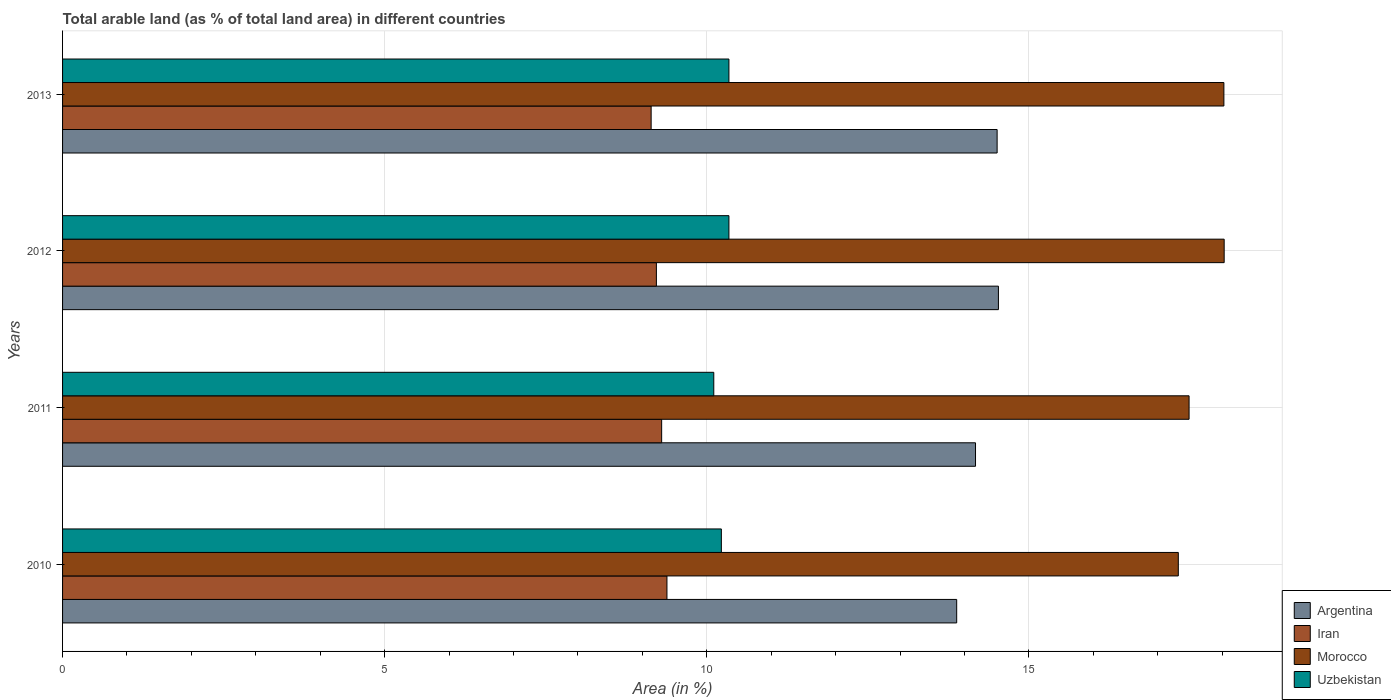How many different coloured bars are there?
Your answer should be very brief. 4. How many groups of bars are there?
Your response must be concise. 4. Are the number of bars per tick equal to the number of legend labels?
Your answer should be compact. Yes. Are the number of bars on each tick of the Y-axis equal?
Your answer should be compact. Yes. What is the label of the 1st group of bars from the top?
Offer a very short reply. 2013. In how many cases, is the number of bars for a given year not equal to the number of legend labels?
Offer a terse response. 0. What is the percentage of arable land in Uzbekistan in 2013?
Offer a terse response. 10.34. Across all years, what is the maximum percentage of arable land in Uzbekistan?
Ensure brevity in your answer.  10.34. Across all years, what is the minimum percentage of arable land in Uzbekistan?
Provide a succinct answer. 10.11. What is the total percentage of arable land in Iran in the graph?
Your answer should be compact. 37.03. What is the difference between the percentage of arable land in Morocco in 2010 and that in 2012?
Your response must be concise. -0.71. What is the difference between the percentage of arable land in Argentina in 2011 and the percentage of arable land in Morocco in 2012?
Ensure brevity in your answer.  -3.86. What is the average percentage of arable land in Uzbekistan per year?
Keep it short and to the point. 10.26. In the year 2011, what is the difference between the percentage of arable land in Argentina and percentage of arable land in Iran?
Provide a succinct answer. 4.87. What is the ratio of the percentage of arable land in Uzbekistan in 2010 to that in 2013?
Give a very brief answer. 0.99. Is the percentage of arable land in Argentina in 2011 less than that in 2012?
Your answer should be compact. Yes. What is the difference between the highest and the second highest percentage of arable land in Uzbekistan?
Your response must be concise. 0. What is the difference between the highest and the lowest percentage of arable land in Uzbekistan?
Your answer should be compact. 0.24. Is the sum of the percentage of arable land in Iran in 2010 and 2012 greater than the maximum percentage of arable land in Morocco across all years?
Offer a terse response. Yes. What does the 3rd bar from the top in 2011 represents?
Give a very brief answer. Iran. What does the 1st bar from the bottom in 2010 represents?
Give a very brief answer. Argentina. Is it the case that in every year, the sum of the percentage of arable land in Uzbekistan and percentage of arable land in Morocco is greater than the percentage of arable land in Argentina?
Offer a terse response. Yes. Are all the bars in the graph horizontal?
Your response must be concise. Yes. What is the difference between two consecutive major ticks on the X-axis?
Keep it short and to the point. 5. Are the values on the major ticks of X-axis written in scientific E-notation?
Offer a terse response. No. Does the graph contain any zero values?
Keep it short and to the point. No. How are the legend labels stacked?
Provide a short and direct response. Vertical. What is the title of the graph?
Keep it short and to the point. Total arable land (as % of total land area) in different countries. Does "Qatar" appear as one of the legend labels in the graph?
Your response must be concise. No. What is the label or title of the X-axis?
Ensure brevity in your answer.  Area (in %). What is the Area (in %) of Argentina in 2010?
Give a very brief answer. 13.88. What is the Area (in %) of Iran in 2010?
Your answer should be compact. 9.38. What is the Area (in %) in Morocco in 2010?
Your answer should be compact. 17.32. What is the Area (in %) of Uzbekistan in 2010?
Your answer should be compact. 10.23. What is the Area (in %) of Argentina in 2011?
Ensure brevity in your answer.  14.17. What is the Area (in %) in Iran in 2011?
Ensure brevity in your answer.  9.3. What is the Area (in %) in Morocco in 2011?
Provide a succinct answer. 17.49. What is the Area (in %) in Uzbekistan in 2011?
Make the answer very short. 10.11. What is the Area (in %) in Argentina in 2012?
Provide a short and direct response. 14.53. What is the Area (in %) of Iran in 2012?
Make the answer very short. 9.22. What is the Area (in %) in Morocco in 2012?
Make the answer very short. 18.03. What is the Area (in %) of Uzbekistan in 2012?
Your answer should be very brief. 10.34. What is the Area (in %) of Argentina in 2013?
Your answer should be compact. 14.51. What is the Area (in %) in Iran in 2013?
Offer a terse response. 9.14. What is the Area (in %) in Morocco in 2013?
Make the answer very short. 18.03. What is the Area (in %) of Uzbekistan in 2013?
Offer a terse response. 10.34. Across all years, what is the maximum Area (in %) of Argentina?
Make the answer very short. 14.53. Across all years, what is the maximum Area (in %) in Iran?
Keep it short and to the point. 9.38. Across all years, what is the maximum Area (in %) of Morocco?
Provide a short and direct response. 18.03. Across all years, what is the maximum Area (in %) in Uzbekistan?
Provide a short and direct response. 10.34. Across all years, what is the minimum Area (in %) in Argentina?
Make the answer very short. 13.88. Across all years, what is the minimum Area (in %) of Iran?
Your answer should be very brief. 9.14. Across all years, what is the minimum Area (in %) of Morocco?
Give a very brief answer. 17.32. Across all years, what is the minimum Area (in %) in Uzbekistan?
Give a very brief answer. 10.11. What is the total Area (in %) in Argentina in the graph?
Keep it short and to the point. 57.08. What is the total Area (in %) of Iran in the graph?
Provide a succinct answer. 37.03. What is the total Area (in %) in Morocco in the graph?
Ensure brevity in your answer.  70.86. What is the total Area (in %) of Uzbekistan in the graph?
Your answer should be very brief. 41.02. What is the difference between the Area (in %) of Argentina in 2010 and that in 2011?
Ensure brevity in your answer.  -0.29. What is the difference between the Area (in %) of Iran in 2010 and that in 2011?
Your answer should be very brief. 0.08. What is the difference between the Area (in %) of Morocco in 2010 and that in 2011?
Your answer should be very brief. -0.17. What is the difference between the Area (in %) of Uzbekistan in 2010 and that in 2011?
Your answer should be very brief. 0.12. What is the difference between the Area (in %) in Argentina in 2010 and that in 2012?
Provide a short and direct response. -0.65. What is the difference between the Area (in %) in Iran in 2010 and that in 2012?
Give a very brief answer. 0.16. What is the difference between the Area (in %) of Morocco in 2010 and that in 2012?
Offer a terse response. -0.71. What is the difference between the Area (in %) in Uzbekistan in 2010 and that in 2012?
Your answer should be very brief. -0.12. What is the difference between the Area (in %) of Argentina in 2010 and that in 2013?
Provide a succinct answer. -0.63. What is the difference between the Area (in %) in Iran in 2010 and that in 2013?
Your response must be concise. 0.25. What is the difference between the Area (in %) of Morocco in 2010 and that in 2013?
Offer a very short reply. -0.71. What is the difference between the Area (in %) in Uzbekistan in 2010 and that in 2013?
Your answer should be very brief. -0.12. What is the difference between the Area (in %) in Argentina in 2011 and that in 2012?
Keep it short and to the point. -0.36. What is the difference between the Area (in %) in Iran in 2011 and that in 2012?
Provide a succinct answer. 0.08. What is the difference between the Area (in %) in Morocco in 2011 and that in 2012?
Your answer should be compact. -0.54. What is the difference between the Area (in %) in Uzbekistan in 2011 and that in 2012?
Your answer should be compact. -0.24. What is the difference between the Area (in %) of Argentina in 2011 and that in 2013?
Offer a very short reply. -0.34. What is the difference between the Area (in %) in Iran in 2011 and that in 2013?
Provide a succinct answer. 0.16. What is the difference between the Area (in %) of Morocco in 2011 and that in 2013?
Offer a very short reply. -0.54. What is the difference between the Area (in %) of Uzbekistan in 2011 and that in 2013?
Give a very brief answer. -0.24. What is the difference between the Area (in %) in Argentina in 2012 and that in 2013?
Give a very brief answer. 0.02. What is the difference between the Area (in %) of Iran in 2012 and that in 2013?
Keep it short and to the point. 0.08. What is the difference between the Area (in %) of Morocco in 2012 and that in 2013?
Provide a succinct answer. 0. What is the difference between the Area (in %) of Uzbekistan in 2012 and that in 2013?
Your response must be concise. 0. What is the difference between the Area (in %) of Argentina in 2010 and the Area (in %) of Iran in 2011?
Give a very brief answer. 4.58. What is the difference between the Area (in %) in Argentina in 2010 and the Area (in %) in Morocco in 2011?
Your response must be concise. -3.61. What is the difference between the Area (in %) in Argentina in 2010 and the Area (in %) in Uzbekistan in 2011?
Give a very brief answer. 3.77. What is the difference between the Area (in %) of Iran in 2010 and the Area (in %) of Morocco in 2011?
Ensure brevity in your answer.  -8.1. What is the difference between the Area (in %) of Iran in 2010 and the Area (in %) of Uzbekistan in 2011?
Give a very brief answer. -0.73. What is the difference between the Area (in %) of Morocco in 2010 and the Area (in %) of Uzbekistan in 2011?
Your answer should be very brief. 7.21. What is the difference between the Area (in %) of Argentina in 2010 and the Area (in %) of Iran in 2012?
Make the answer very short. 4.66. What is the difference between the Area (in %) in Argentina in 2010 and the Area (in %) in Morocco in 2012?
Your response must be concise. -4.15. What is the difference between the Area (in %) of Argentina in 2010 and the Area (in %) of Uzbekistan in 2012?
Ensure brevity in your answer.  3.54. What is the difference between the Area (in %) of Iran in 2010 and the Area (in %) of Morocco in 2012?
Provide a succinct answer. -8.65. What is the difference between the Area (in %) of Iran in 2010 and the Area (in %) of Uzbekistan in 2012?
Your answer should be very brief. -0.96. What is the difference between the Area (in %) in Morocco in 2010 and the Area (in %) in Uzbekistan in 2012?
Provide a succinct answer. 6.98. What is the difference between the Area (in %) in Argentina in 2010 and the Area (in %) in Iran in 2013?
Keep it short and to the point. 4.74. What is the difference between the Area (in %) in Argentina in 2010 and the Area (in %) in Morocco in 2013?
Provide a succinct answer. -4.15. What is the difference between the Area (in %) of Argentina in 2010 and the Area (in %) of Uzbekistan in 2013?
Provide a short and direct response. 3.54. What is the difference between the Area (in %) in Iran in 2010 and the Area (in %) in Morocco in 2013?
Make the answer very short. -8.64. What is the difference between the Area (in %) in Iran in 2010 and the Area (in %) in Uzbekistan in 2013?
Your answer should be very brief. -0.96. What is the difference between the Area (in %) of Morocco in 2010 and the Area (in %) of Uzbekistan in 2013?
Offer a very short reply. 6.98. What is the difference between the Area (in %) of Argentina in 2011 and the Area (in %) of Iran in 2012?
Your answer should be very brief. 4.95. What is the difference between the Area (in %) in Argentina in 2011 and the Area (in %) in Morocco in 2012?
Keep it short and to the point. -3.86. What is the difference between the Area (in %) of Argentina in 2011 and the Area (in %) of Uzbekistan in 2012?
Provide a short and direct response. 3.83. What is the difference between the Area (in %) in Iran in 2011 and the Area (in %) in Morocco in 2012?
Your answer should be compact. -8.73. What is the difference between the Area (in %) of Iran in 2011 and the Area (in %) of Uzbekistan in 2012?
Make the answer very short. -1.04. What is the difference between the Area (in %) in Morocco in 2011 and the Area (in %) in Uzbekistan in 2012?
Ensure brevity in your answer.  7.14. What is the difference between the Area (in %) of Argentina in 2011 and the Area (in %) of Iran in 2013?
Your response must be concise. 5.04. What is the difference between the Area (in %) of Argentina in 2011 and the Area (in %) of Morocco in 2013?
Keep it short and to the point. -3.86. What is the difference between the Area (in %) of Argentina in 2011 and the Area (in %) of Uzbekistan in 2013?
Provide a short and direct response. 3.83. What is the difference between the Area (in %) of Iran in 2011 and the Area (in %) of Morocco in 2013?
Provide a succinct answer. -8.73. What is the difference between the Area (in %) of Iran in 2011 and the Area (in %) of Uzbekistan in 2013?
Your answer should be compact. -1.04. What is the difference between the Area (in %) of Morocco in 2011 and the Area (in %) of Uzbekistan in 2013?
Offer a terse response. 7.14. What is the difference between the Area (in %) in Argentina in 2012 and the Area (in %) in Iran in 2013?
Offer a terse response. 5.39. What is the difference between the Area (in %) in Argentina in 2012 and the Area (in %) in Morocco in 2013?
Your answer should be compact. -3.5. What is the difference between the Area (in %) of Argentina in 2012 and the Area (in %) of Uzbekistan in 2013?
Your answer should be compact. 4.18. What is the difference between the Area (in %) in Iran in 2012 and the Area (in %) in Morocco in 2013?
Offer a terse response. -8.81. What is the difference between the Area (in %) in Iran in 2012 and the Area (in %) in Uzbekistan in 2013?
Your answer should be compact. -1.13. What is the difference between the Area (in %) of Morocco in 2012 and the Area (in %) of Uzbekistan in 2013?
Provide a succinct answer. 7.69. What is the average Area (in %) in Argentina per year?
Give a very brief answer. 14.27. What is the average Area (in %) in Iran per year?
Make the answer very short. 9.26. What is the average Area (in %) in Morocco per year?
Your answer should be very brief. 17.72. What is the average Area (in %) in Uzbekistan per year?
Make the answer very short. 10.26. In the year 2010, what is the difference between the Area (in %) in Argentina and Area (in %) in Iran?
Offer a terse response. 4.5. In the year 2010, what is the difference between the Area (in %) of Argentina and Area (in %) of Morocco?
Make the answer very short. -3.44. In the year 2010, what is the difference between the Area (in %) in Argentina and Area (in %) in Uzbekistan?
Ensure brevity in your answer.  3.65. In the year 2010, what is the difference between the Area (in %) of Iran and Area (in %) of Morocco?
Offer a terse response. -7.94. In the year 2010, what is the difference between the Area (in %) in Iran and Area (in %) in Uzbekistan?
Your answer should be very brief. -0.84. In the year 2010, what is the difference between the Area (in %) of Morocco and Area (in %) of Uzbekistan?
Make the answer very short. 7.09. In the year 2011, what is the difference between the Area (in %) in Argentina and Area (in %) in Iran?
Your answer should be compact. 4.87. In the year 2011, what is the difference between the Area (in %) in Argentina and Area (in %) in Morocco?
Offer a terse response. -3.31. In the year 2011, what is the difference between the Area (in %) in Argentina and Area (in %) in Uzbekistan?
Your answer should be compact. 4.06. In the year 2011, what is the difference between the Area (in %) in Iran and Area (in %) in Morocco?
Your answer should be compact. -8.19. In the year 2011, what is the difference between the Area (in %) in Iran and Area (in %) in Uzbekistan?
Offer a very short reply. -0.81. In the year 2011, what is the difference between the Area (in %) of Morocco and Area (in %) of Uzbekistan?
Give a very brief answer. 7.38. In the year 2012, what is the difference between the Area (in %) in Argentina and Area (in %) in Iran?
Keep it short and to the point. 5.31. In the year 2012, what is the difference between the Area (in %) in Argentina and Area (in %) in Morocco?
Provide a succinct answer. -3.5. In the year 2012, what is the difference between the Area (in %) in Argentina and Area (in %) in Uzbekistan?
Provide a succinct answer. 4.18. In the year 2012, what is the difference between the Area (in %) of Iran and Area (in %) of Morocco?
Your response must be concise. -8.81. In the year 2012, what is the difference between the Area (in %) in Iran and Area (in %) in Uzbekistan?
Ensure brevity in your answer.  -1.13. In the year 2012, what is the difference between the Area (in %) of Morocco and Area (in %) of Uzbekistan?
Offer a terse response. 7.69. In the year 2013, what is the difference between the Area (in %) of Argentina and Area (in %) of Iran?
Give a very brief answer. 5.37. In the year 2013, what is the difference between the Area (in %) in Argentina and Area (in %) in Morocco?
Provide a short and direct response. -3.52. In the year 2013, what is the difference between the Area (in %) in Argentina and Area (in %) in Uzbekistan?
Your answer should be very brief. 4.16. In the year 2013, what is the difference between the Area (in %) in Iran and Area (in %) in Morocco?
Provide a short and direct response. -8.89. In the year 2013, what is the difference between the Area (in %) in Iran and Area (in %) in Uzbekistan?
Offer a very short reply. -1.21. In the year 2013, what is the difference between the Area (in %) of Morocco and Area (in %) of Uzbekistan?
Your answer should be compact. 7.68. What is the ratio of the Area (in %) of Argentina in 2010 to that in 2011?
Provide a short and direct response. 0.98. What is the ratio of the Area (in %) in Iran in 2010 to that in 2011?
Give a very brief answer. 1.01. What is the ratio of the Area (in %) in Morocco in 2010 to that in 2011?
Provide a succinct answer. 0.99. What is the ratio of the Area (in %) in Uzbekistan in 2010 to that in 2011?
Provide a succinct answer. 1.01. What is the ratio of the Area (in %) of Argentina in 2010 to that in 2012?
Your answer should be very brief. 0.96. What is the ratio of the Area (in %) of Iran in 2010 to that in 2012?
Your response must be concise. 1.02. What is the ratio of the Area (in %) of Morocco in 2010 to that in 2012?
Give a very brief answer. 0.96. What is the ratio of the Area (in %) of Uzbekistan in 2010 to that in 2012?
Your answer should be very brief. 0.99. What is the ratio of the Area (in %) of Argentina in 2010 to that in 2013?
Ensure brevity in your answer.  0.96. What is the ratio of the Area (in %) in Iran in 2010 to that in 2013?
Your response must be concise. 1.03. What is the ratio of the Area (in %) in Morocco in 2010 to that in 2013?
Give a very brief answer. 0.96. What is the ratio of the Area (in %) of Argentina in 2011 to that in 2012?
Make the answer very short. 0.98. What is the ratio of the Area (in %) in Iran in 2011 to that in 2012?
Your answer should be very brief. 1.01. What is the ratio of the Area (in %) in Morocco in 2011 to that in 2012?
Keep it short and to the point. 0.97. What is the ratio of the Area (in %) in Uzbekistan in 2011 to that in 2012?
Ensure brevity in your answer.  0.98. What is the ratio of the Area (in %) of Argentina in 2011 to that in 2013?
Your answer should be compact. 0.98. What is the ratio of the Area (in %) in Iran in 2011 to that in 2013?
Your response must be concise. 1.02. What is the ratio of the Area (in %) in Uzbekistan in 2011 to that in 2013?
Provide a short and direct response. 0.98. What is the ratio of the Area (in %) in Argentina in 2012 to that in 2013?
Keep it short and to the point. 1. What is the ratio of the Area (in %) of Iran in 2012 to that in 2013?
Keep it short and to the point. 1.01. What is the ratio of the Area (in %) of Morocco in 2012 to that in 2013?
Ensure brevity in your answer.  1. What is the ratio of the Area (in %) in Uzbekistan in 2012 to that in 2013?
Give a very brief answer. 1. What is the difference between the highest and the second highest Area (in %) in Argentina?
Offer a terse response. 0.02. What is the difference between the highest and the second highest Area (in %) in Iran?
Make the answer very short. 0.08. What is the difference between the highest and the second highest Area (in %) of Morocco?
Provide a short and direct response. 0. What is the difference between the highest and the lowest Area (in %) of Argentina?
Your response must be concise. 0.65. What is the difference between the highest and the lowest Area (in %) in Iran?
Your answer should be compact. 0.25. What is the difference between the highest and the lowest Area (in %) in Morocco?
Your answer should be very brief. 0.71. What is the difference between the highest and the lowest Area (in %) of Uzbekistan?
Keep it short and to the point. 0.24. 